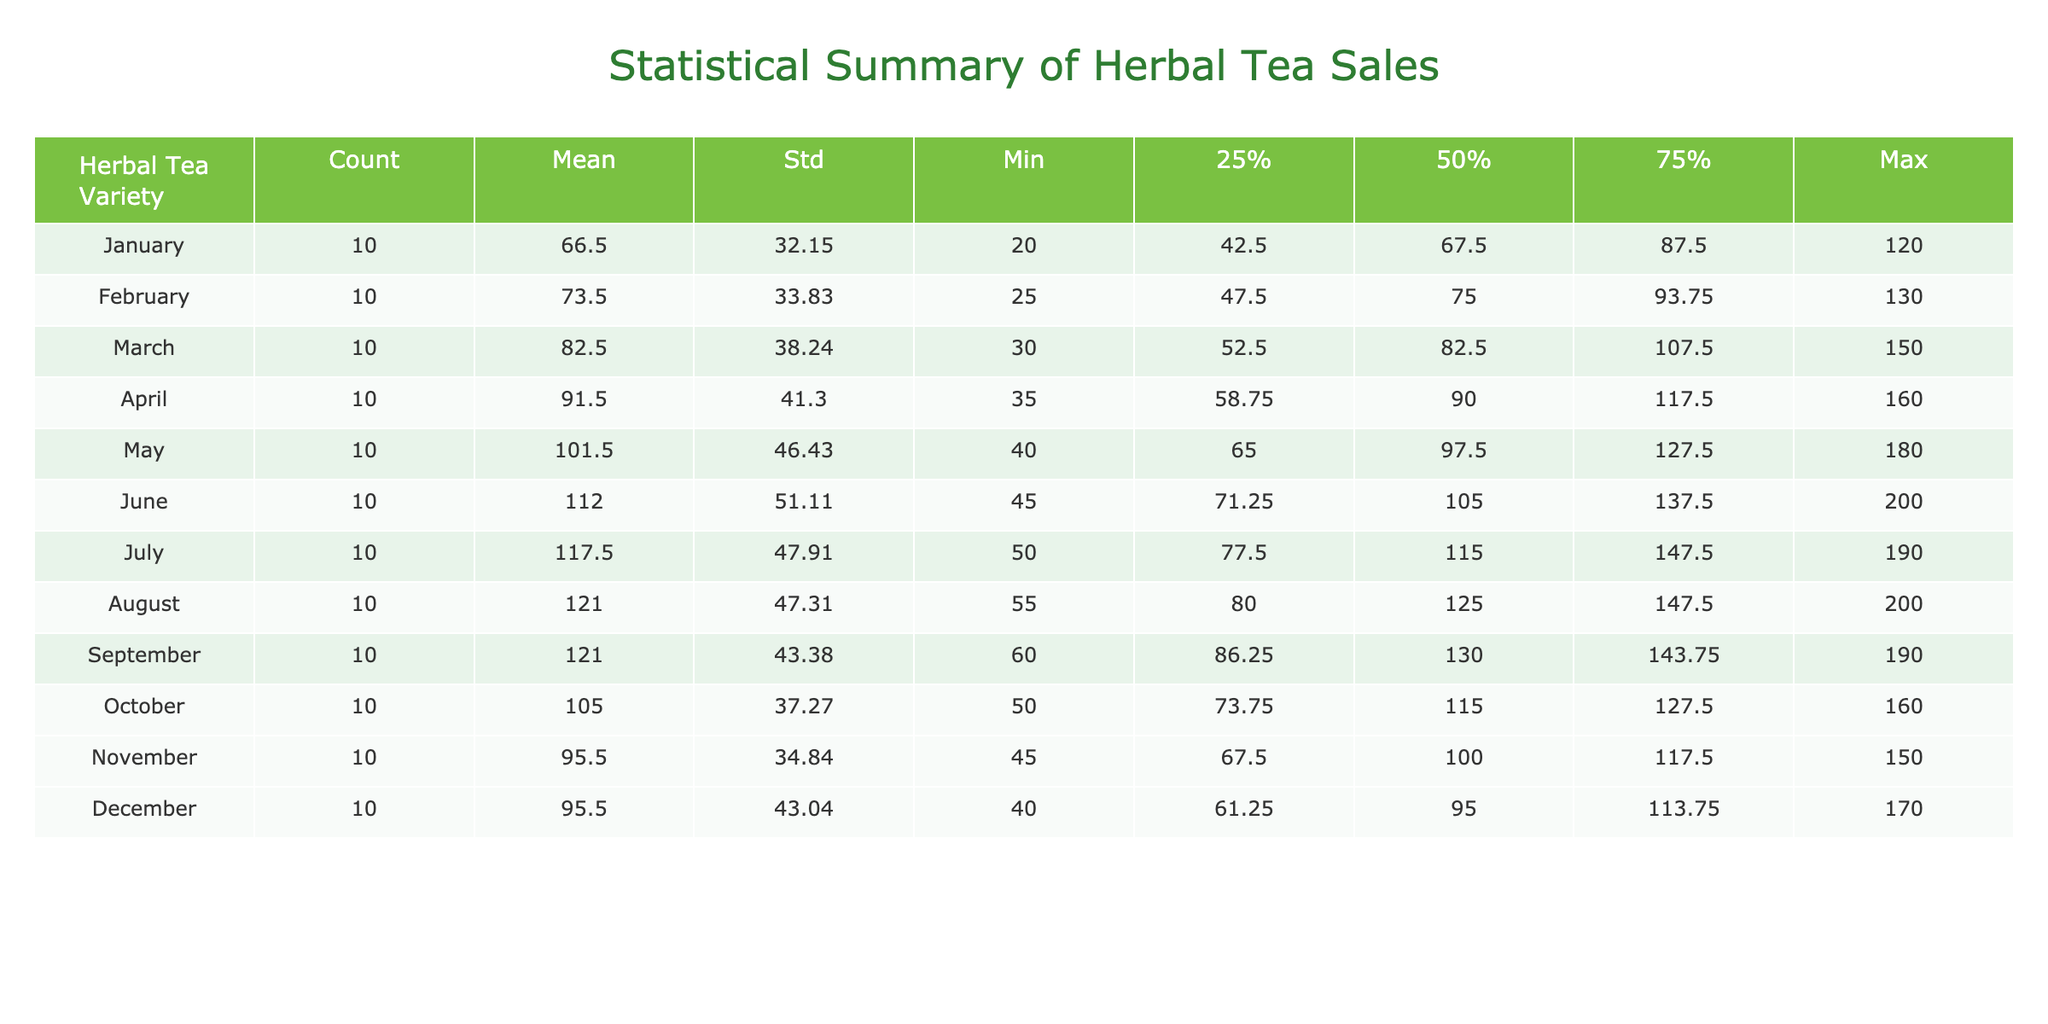What was the total sales of Chamomile tea for the year? To find the total sales for Chamomile, we will add the monthly sales figures: 120 + 130 + 150 + 160 + 180 + 200 + 190 + 170 + 160 + 140 + 130 + 150 = 1,920.
Answer: 1920 Which herbal tea variety had the lowest mean monthly sales? To determine which tea had the lowest mean sales, we look at the mean values and find that Echinacea has a mean of 55.42, which is the lowest compared to others.
Answer: Echinacea Is it true that Lavender tea had more sales in August than in February? By comparing the sales figures, Lavender had 130 sales in August and 70 in February. Since 130 > 70, this statement is true.
Answer: Yes What is the difference between the maximum and minimum sales for Rooibos? The maximum sales for Rooibos is 130 and the minimum is 75. The difference is calculated as 130 - 75 = 55.
Answer: 55 On which month did Hibiscus tea achieve its highest sales? By looking at the monthly sales for Hibiscus, the highest sales of 200 occurred in August.
Answer: August What’s the average sales of Ginger tea over the year? To find the average, we first sum the monthly sales: 90 + 95 + 100 + 110 + 120 + 130 + 140 + 150 + 145 + 130 + 120 + 115 = 1,350. Then we divide 1,350 by 12 (months), resulting in an average of 112.5.
Answer: 112.5 Did Lemon Balm sell more in May than in June? Lemon Balm sales were 80 in May and 90 in June. Since 90 > 80, Lemon Balm sold more in June, making the statement false.
Answer: No Which tea had the highest standard deviation in sales over the year? We compare the standard deviations from the table, and we see that Chamomile has the highest standard deviation of 40.46, indicating it had the most variability in sales.
Answer: Chamomile 